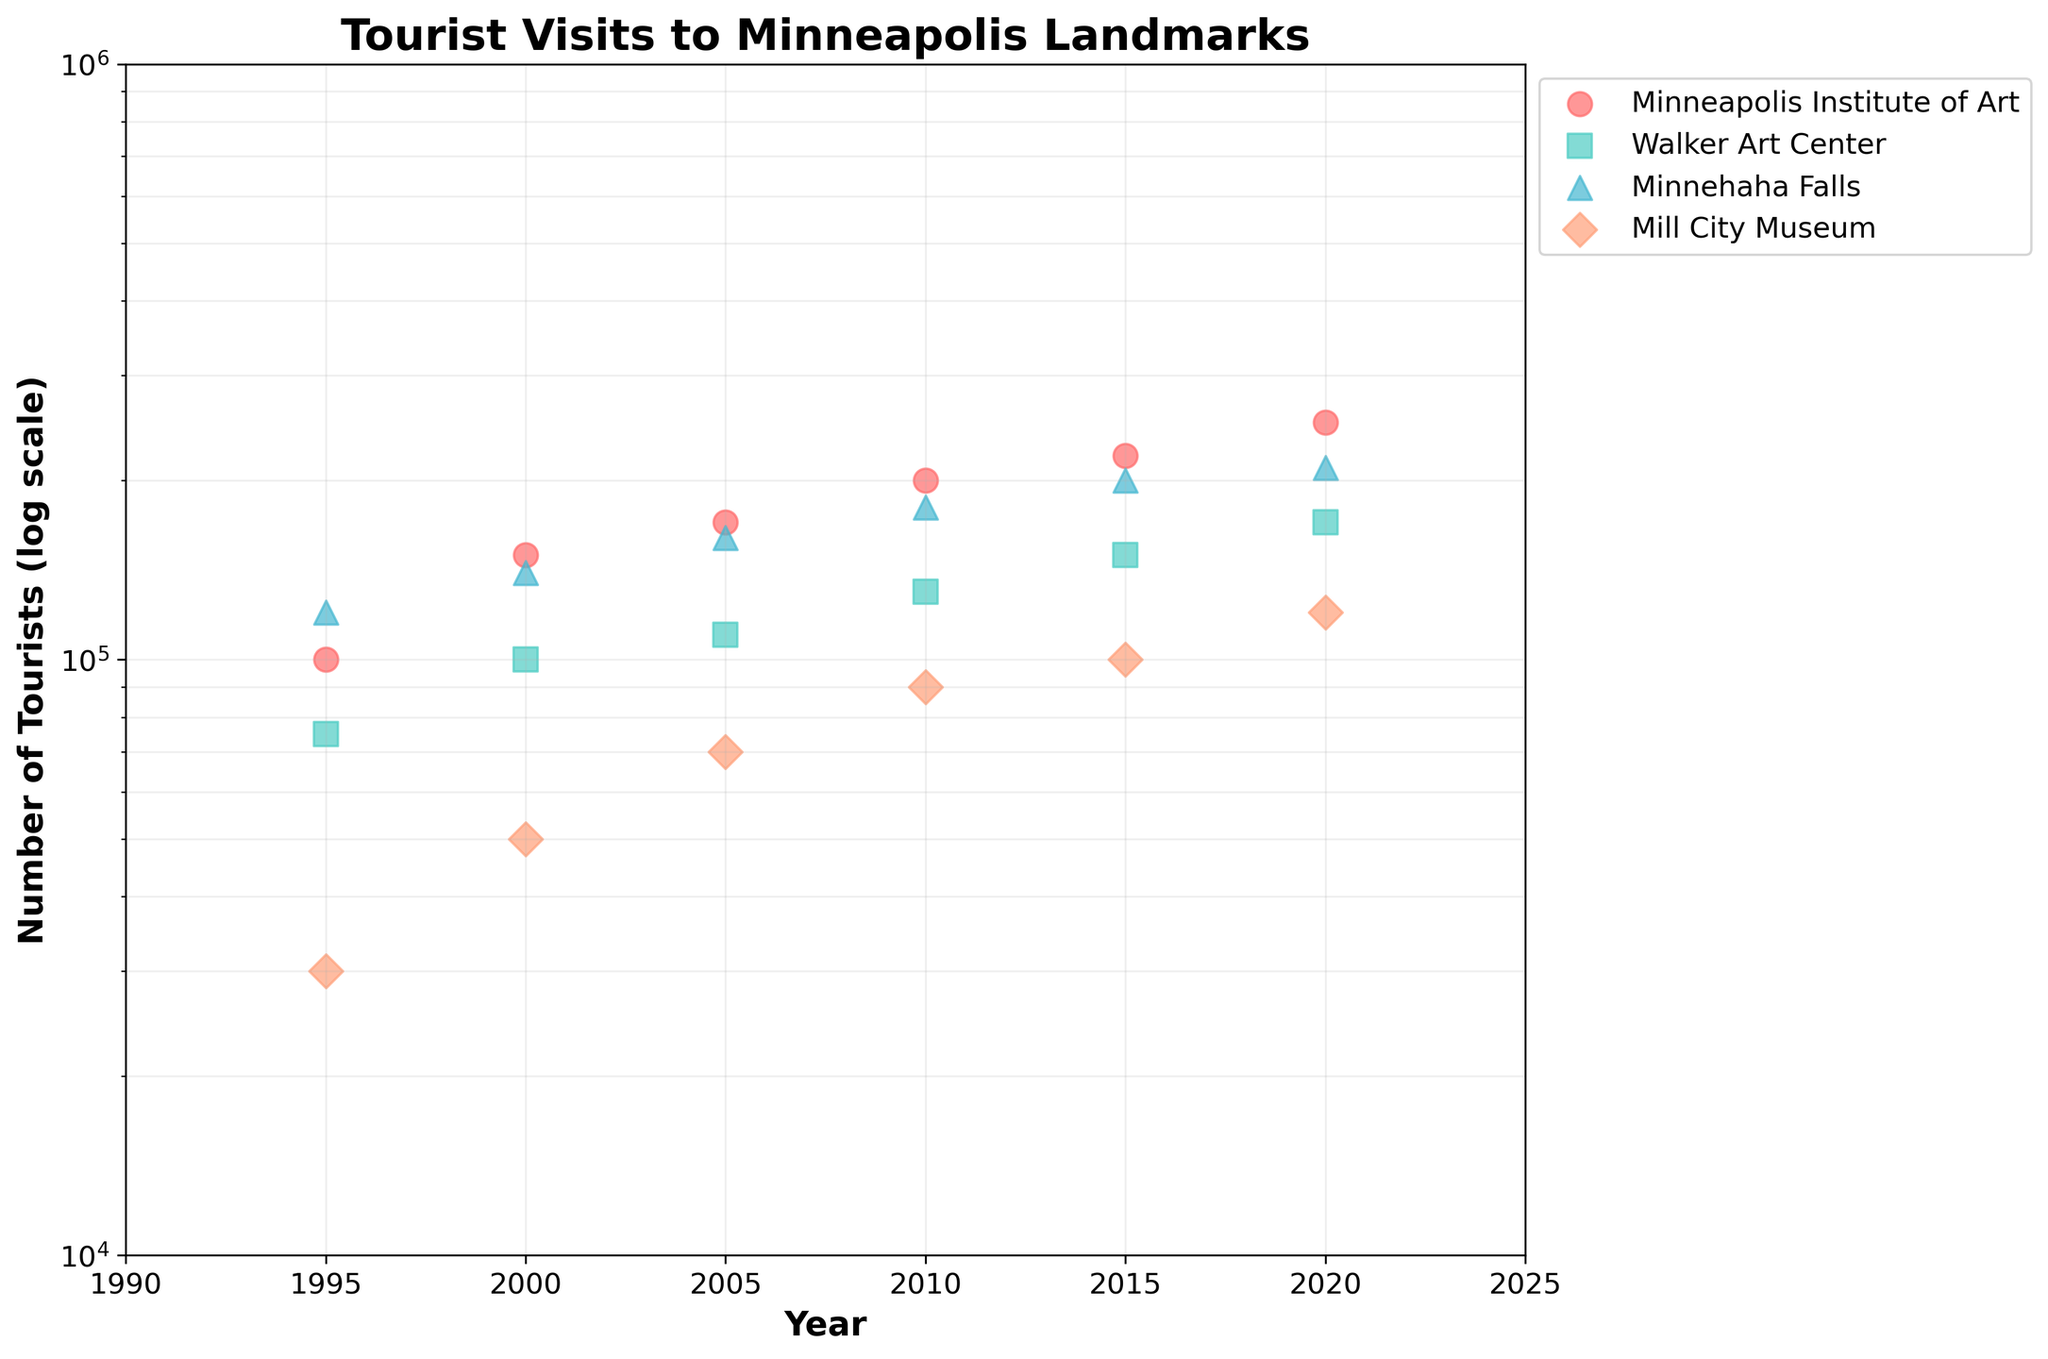what is the title of the plot? The title is located at the top of the plot and indicates the main subject of the visualized data. The title is "Tourist Visits to Minneapolis Landmarks".
Answer: Tourist Visits to Minneapolis Landmarks How many unique landmarks are represented in the figure? By looking at the legend, which lists landmarks by name and color, we can identify the unique landmarks. There are four unique landmarks.
Answer: Four Which landmark had the highest number of tourists in the year 2020? Referring to the one with the highest value on the y-axis at the year 2020. Minnehaha Falls had the highest number of tourists in 2020.
Answer: Minnehaha Falls What is the general trend for the number of tourists visiting the Walker Art Center from 1995 to 2020? Following the data points for the Walker Art Center from 1995 to 2020, its trend can be observed. The number of tourists visiting the Walker Art Center generally increased over the years.
Answer: Increasing What was the percentage increase in tourists visiting the Mill City Museum from 1995 to 2020? To find the percentage increase, calculate the difference (120000 - 30000) and then divide by the initial value (30000), and multiply by 100: Percentage Increase = [(120000-30000)/30000]*100
Answer: 300% Which landmark had a more substantial increase in tourists from 1995 to 2005, Minnehaha Falls or the Walker Art Center? Comparing the increase in numbers for both: Minnehaha Falls increased from 120000 to 160000 (40000) and Walker Art Center from 75000 to 110000 (35000). Minnehaha Falls had a more substantial increase.
Answer: Minnehaha Falls How many total tourists visited the Minneapolis Institute of Art and the Walker Art Center in 2010? Sum the data points for both landmarks in 2010: Minneapolis Institute of Art (200000) + Walker Art Center (130000) = 330000.
Answer: 330000 Which years have data points for the Walker Art Center? Identify the years when data points for Walker Art Center appear. The years are 1995, 2000, 2005, 2010, 2015, and 2020.
Answer: 1995, 2000, 2005, 2010, 2015, 2020 Between which two consecutive years did Minnehaha Falls see the smallest increase in tourists? Calculate the increases between consecutive years for Minnehaha Falls: 1995-2000 (20000), 2000-2005 (20000), 2005-2010 (20000), 2010-2015 (20000), 2015-2020 (10000). The smallest increase was between 2015 and 2020.
Answer: 2015 and 2020 